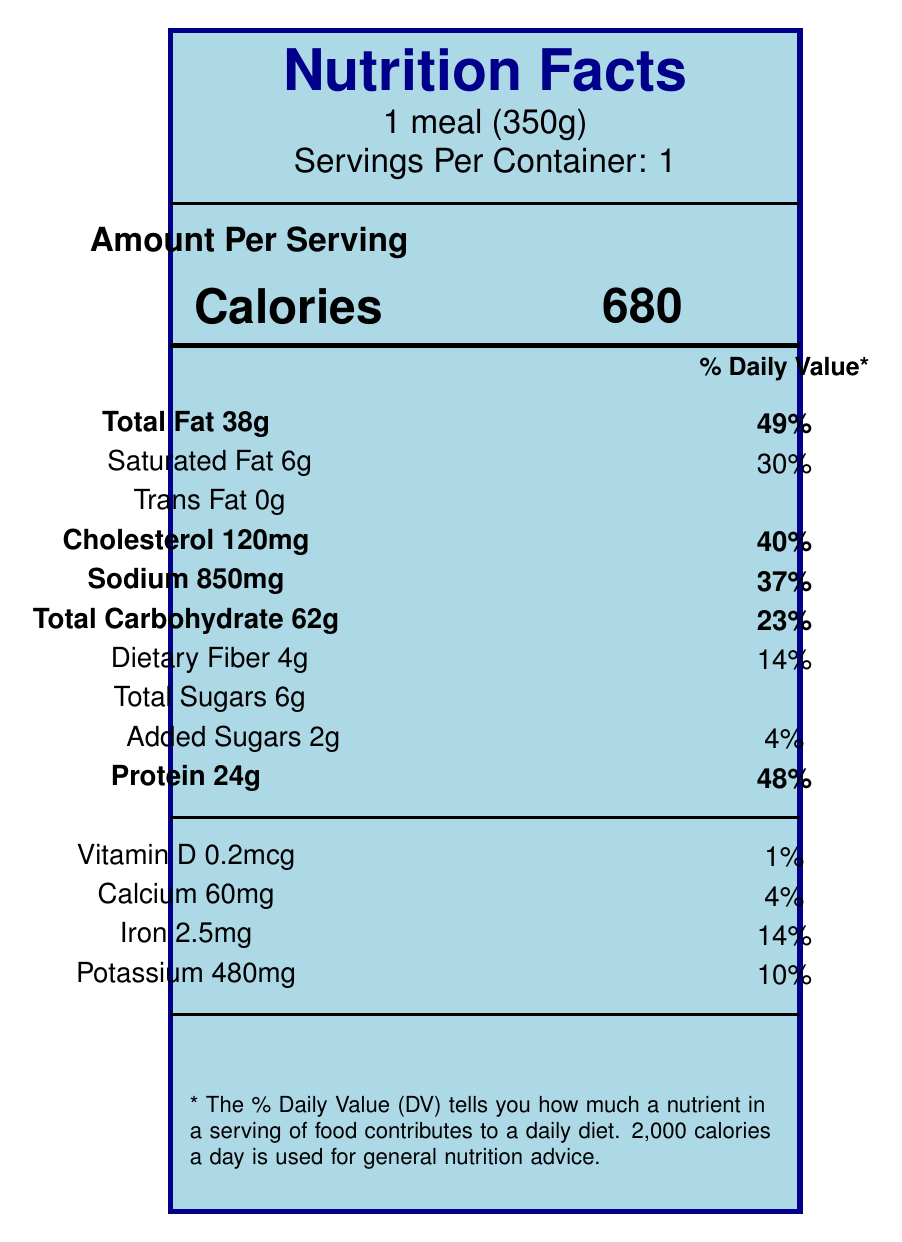what is the serving size? The serving size is located at the top of the document and specifies "1 meal (350g)".
Answer: 1 meal (350g) how many calories are in one serving of the tempura meal? The number of calories per serving is prominently displayed near the top center of the document, indicating 680 calories.
Answer: 680 what is the total fat content per serving, and what percentage of the daily value does it represent? The document lists the total fat content as 38 grams per serving and also shows that this amount represents 49% of the daily value.
Answer: 38g, 49% how many grams of protein are in one serving of this tempura meal? The document indicates that there are 24 grams of protein per serving, found under the "Protein" section.
Answer: 24g what is the cholesterol content and its percentage daily value? The cholesterol content is 120 milligrams, which is 40% of the daily value, as shown in the respective section of the document.
Answer: 120mg, 40% which of the following nutrients has the lowest percentage daily value: vitamin D, calcium, iron, or potassium? A. Vitamin D B. Calcium C. Iron D. Potassium Vitamin D has the lowest percentage daily value at 1%, compared to calcium (4%), iron (14%), and potassium (10%).
Answer: A what is the sodium content in one serving, and what percentage of the daily value does it represent? The sodium content is listed as 850 milligrams per serving, which corresponds to 37% of the daily value.
Answer: 850mg, 37% which nutrient contributes 23% to the daily value? A. Total Fat B. Protein C. Total Carbohydrate D. Dietary Fiber Total Carbohydrate contributes 23% to the daily value, as indicated by the document.
Answer: C is there any trans fat in this tempura meal? The document clearly states "Trans Fat 0g," indicating there is no trans fat in this meal.
Answer: No summarize the nutritional information provided in the document. The document thoroughly details the nutritional content of the tempura meal, specifying the grams or milligrams of each component and its corresponding daily value percentage.
Answer: The document provides nutritional information for a tempura meal, including calorie count, amounts of various fats, cholesterol, sodium, carbohydrates, dietary fiber, total sugars, added sugars, protein, and specific vitamins and minerals. It also provides the percentage of the daily value for each nutrient. how many different named allergens are present in this meal? The document provided does not specify the number of named allergens; it requires information from the non-visual part of the document.
Answer: Not enough information 